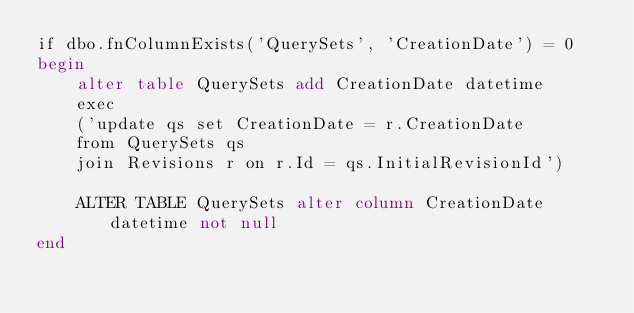<code> <loc_0><loc_0><loc_500><loc_500><_SQL_>if dbo.fnColumnExists('QuerySets', 'CreationDate') = 0
begin
	alter table QuerySets add CreationDate datetime
	exec
	('update qs set CreationDate = r.CreationDate
	from QuerySets qs 
	join Revisions r on r.Id = qs.InitialRevisionId')
	
	ALTER TABLE QuerySets alter column CreationDate datetime not null
end</code> 